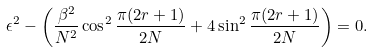Convert formula to latex. <formula><loc_0><loc_0><loc_500><loc_500>\epsilon ^ { 2 } - \left ( \frac { \beta ^ { 2 } } { N ^ { 2 } } \cos ^ { 2 } \frac { \pi ( 2 r + 1 ) } { 2 N } + 4 \sin ^ { 2 } \frac { \pi ( 2 r + 1 ) } { 2 N } \right ) = 0 .</formula> 